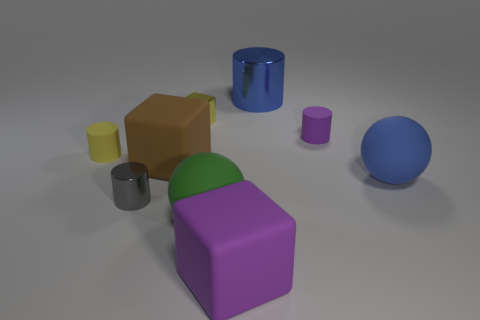Subtract all big cubes. How many cubes are left? 1 Add 1 small yellow shiny balls. How many objects exist? 10 Subtract all gray cylinders. How many cylinders are left? 3 Subtract all cylinders. How many objects are left? 5 Subtract 2 balls. How many balls are left? 0 Subtract all blue blocks. Subtract all brown cylinders. How many blocks are left? 3 Subtract all red spheres. How many brown blocks are left? 1 Subtract all blue rubber cylinders. Subtract all metal blocks. How many objects are left? 8 Add 5 yellow cubes. How many yellow cubes are left? 6 Add 5 big green matte things. How many big green matte things exist? 6 